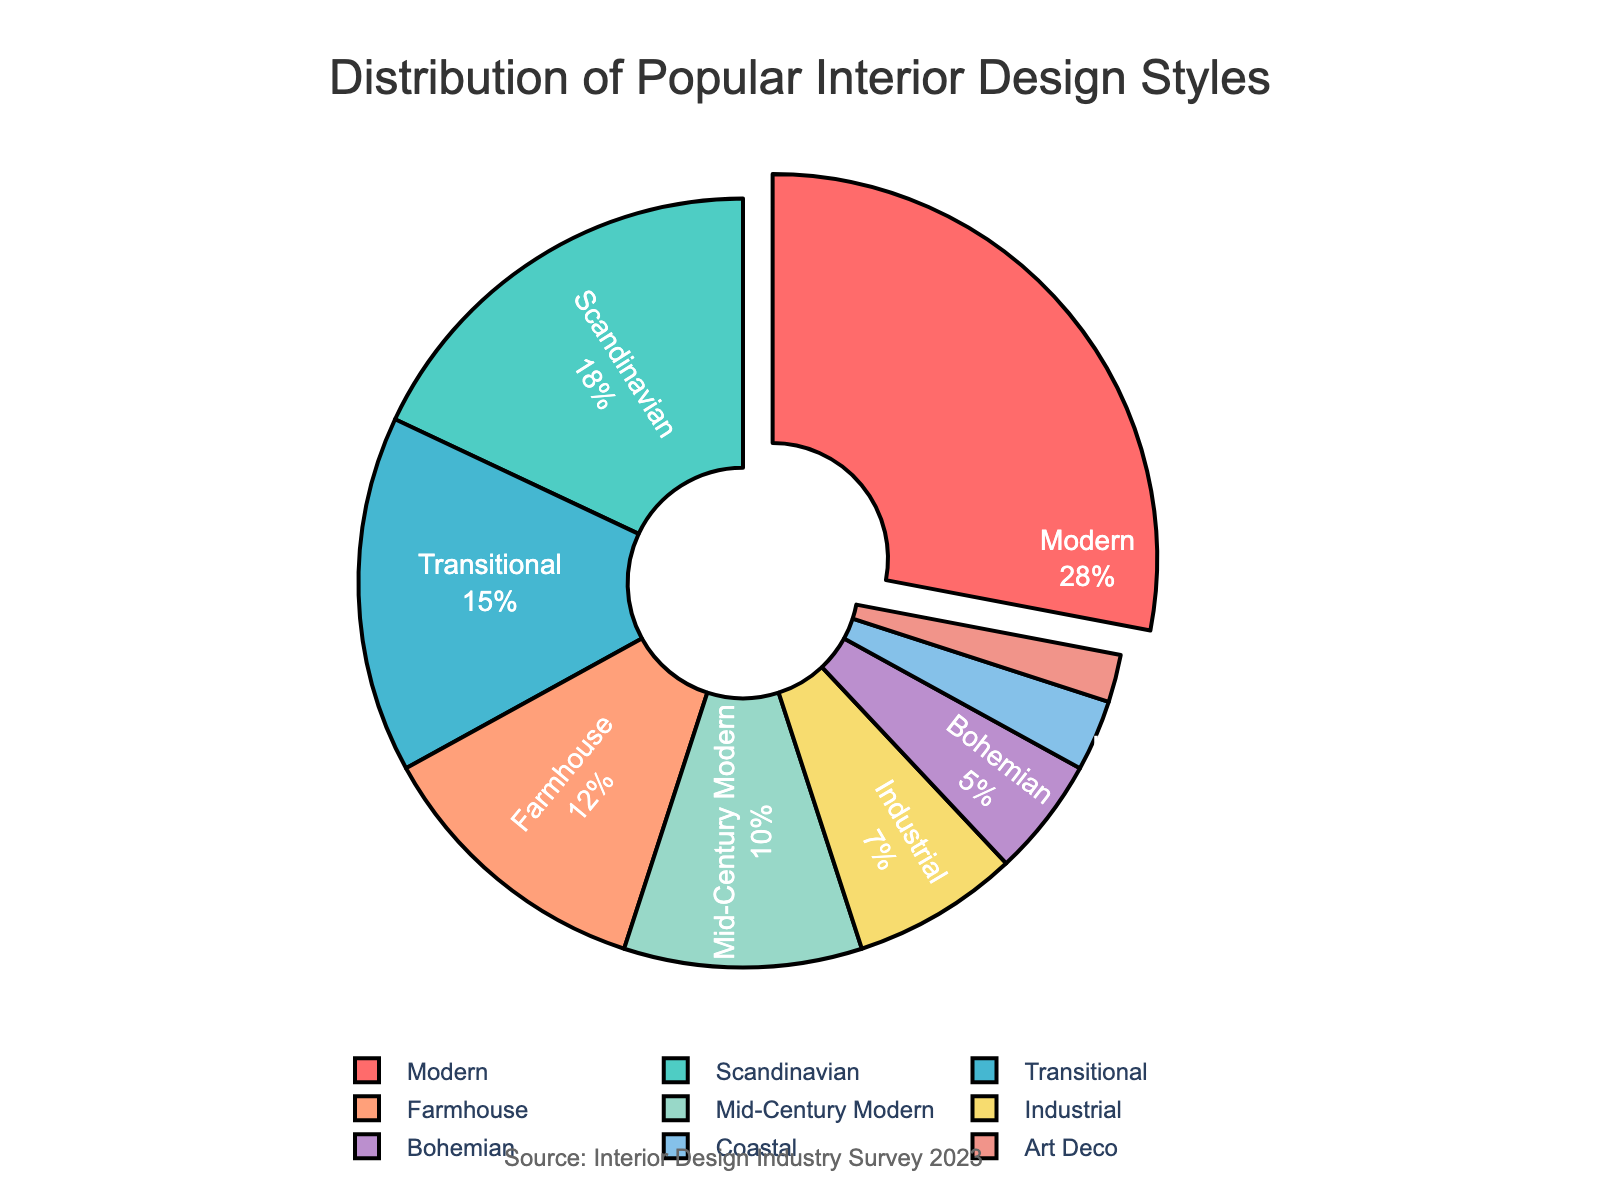what percentage of the projects use Modern or Scandinavian styles together? First, identify the percentages for Modern (28%) and Scandinavian (18%). Then, sum them up: 28% + 18% to find the total percentage for both styles combined.
Answer: 46% Which style has the lowest percentage? Examine the pie chart to identify the smallest segment, corresponding to the style with the lowest percentage. In this case, the smallest segment represents Art Deco with 2%.
Answer: Art Deco How much more popular is the Modern style compared to the Industrial style? Locate the percentages for Modern (28%) and Industrial (7%). Subtract the Industrial percentage from the Modern percentage: 28% - 7%.
Answer: 21% What are the combined percentages for Farmhouse, Mid-Century Modern, and Industrial styles? Identify and sum the percentages for Farmhouse (12%), Mid-Century Modern (10%), and Industrial (7%): 12% + 10% + 7%.
Answer: 29% Which color represents the Bohemian style, and what is its percentage? Locate the color key for the Bohemian style in the pie chart to identify its color (likely purple) and find its associated percentage (5%).
Answer: Purple, 5% How many styles have a percentage greater than or equal to 10%? Scan the pie chart and count the number of styles with percentages of at least 10%. The styles are Modern (28%), Scandinavian (18%), Transitional (15%), Farmhouse (12%), and Mid-Century Modern (10%).
Answer: 5 Is the sum of the percentages for Coastal, Art Deco, and Bohemian styles more than 10%? Identify and sum the percentages for Coastal (3%), Art Deco (2%), and Bohemian (5%). Calculate the total: 3% + 2% + 5%. Compare the total with 10% to answer the question.
Answer: No Which style is the second most popular? Find the style with the second largest segment in the pie chart. The style is Scandinavian with 18%.
Answer: Scandinavian What percentage of the projects do not use the Modern style? The total percentage is 100%. Subtract the percentage for Modern (28%): 100% - 28%.
Answer: 72% 